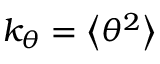Convert formula to latex. <formula><loc_0><loc_0><loc_500><loc_500>k _ { \theta } = \left < \theta ^ { 2 } \right ></formula> 